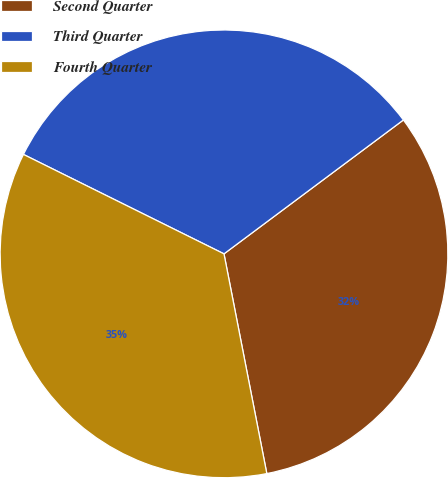Convert chart to OTSL. <chart><loc_0><loc_0><loc_500><loc_500><pie_chart><fcel>Second Quarter<fcel>Third Quarter<fcel>Fourth Quarter<nl><fcel>32.14%<fcel>32.47%<fcel>35.39%<nl></chart> 